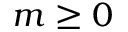Convert formula to latex. <formula><loc_0><loc_0><loc_500><loc_500>m \geq 0</formula> 